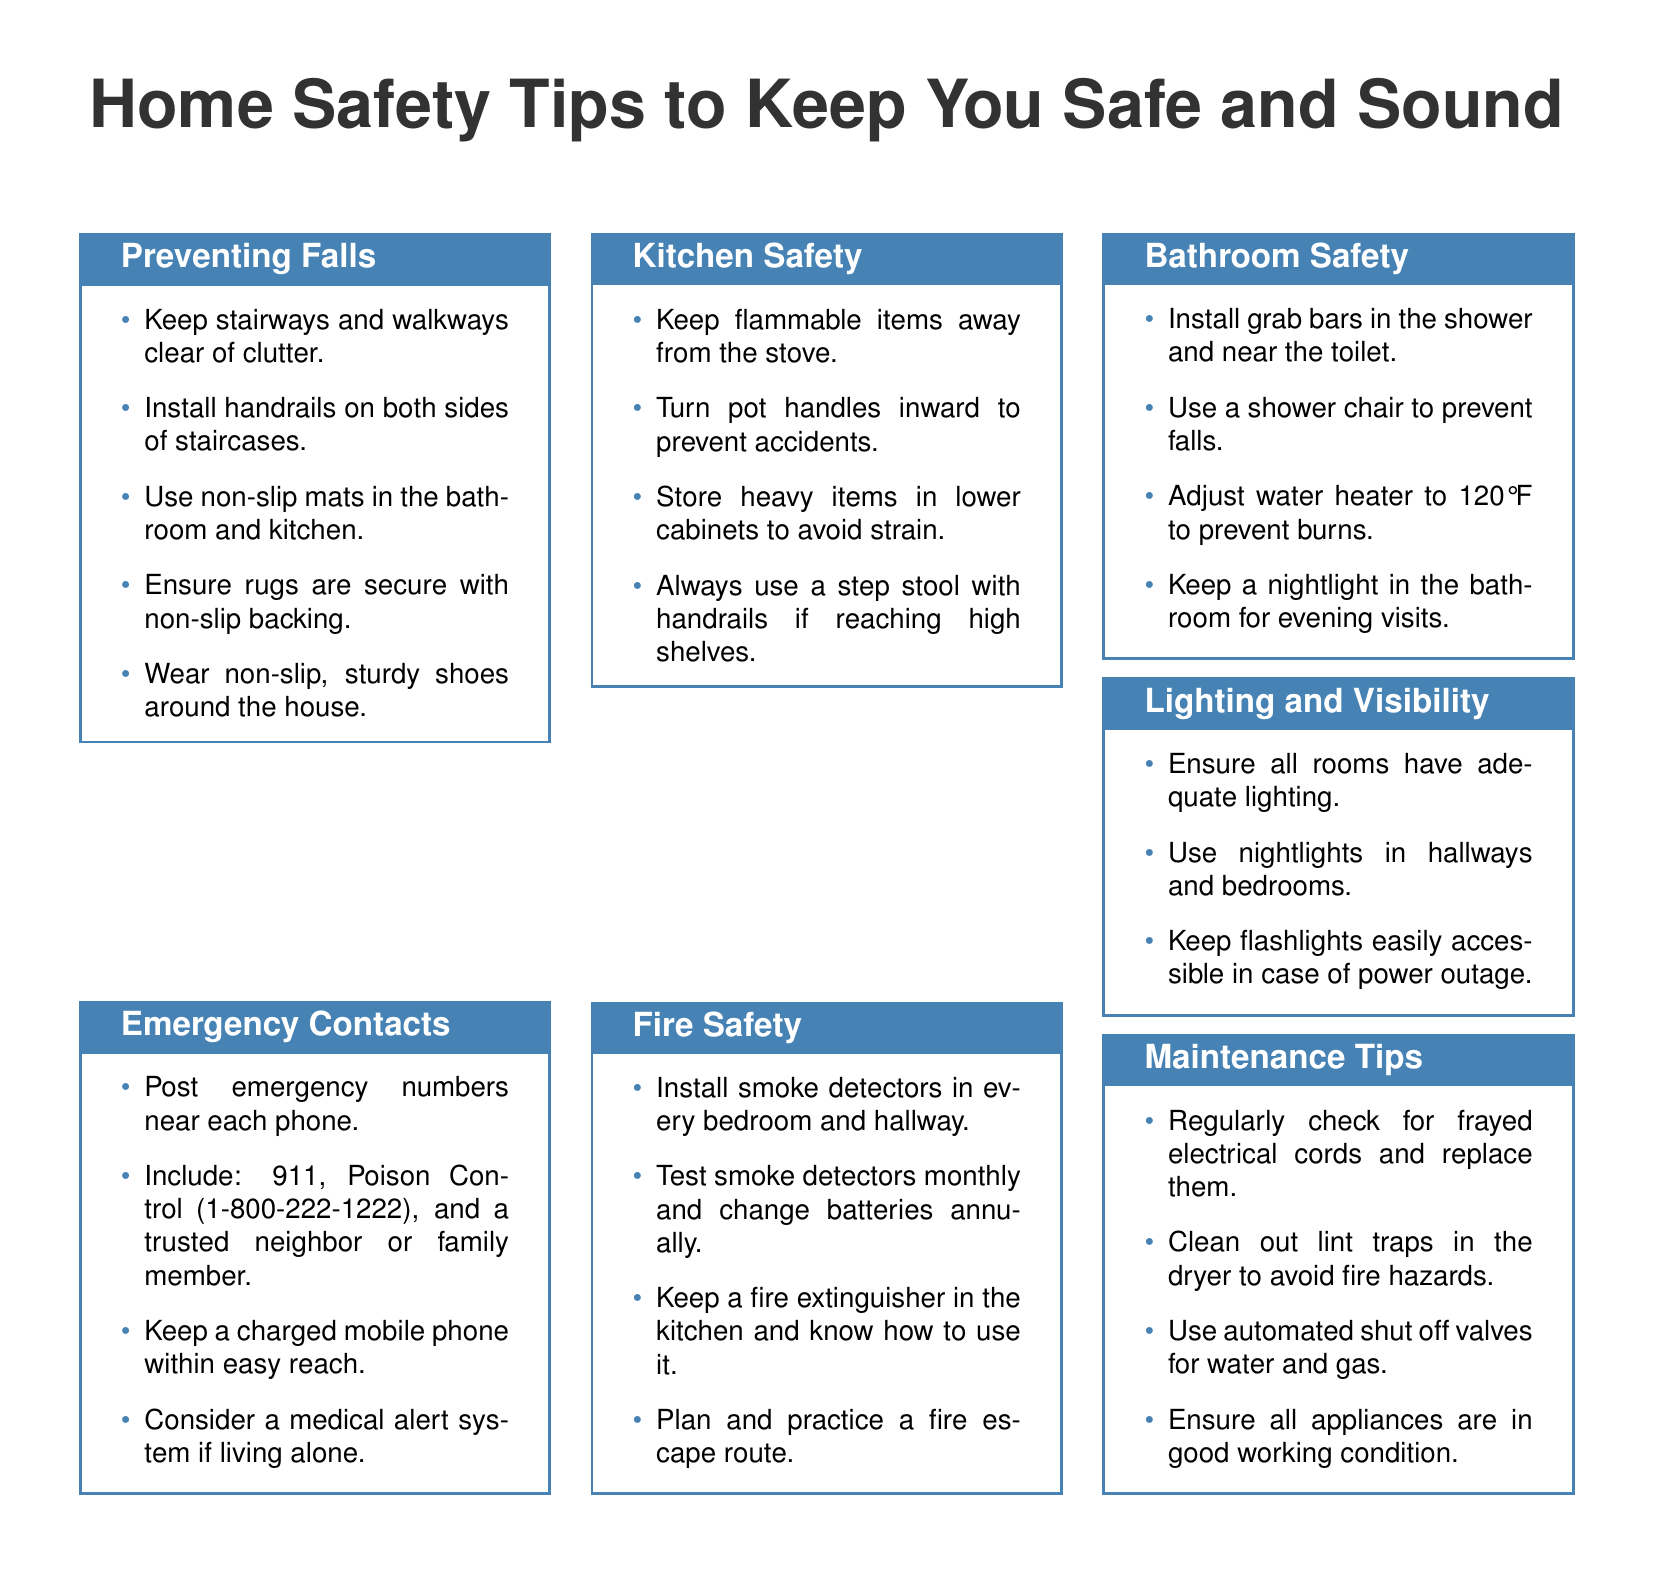What are two items to keep near each phone? The document lists emergency numbers, including 911 and Poison Control, that should be posted near each phone.
Answer: 911, Poison Control How many smoke detectors should be installed? The document states that smoke detectors should be installed in every bedroom and hallway, implying multiple units.
Answer: Every bedroom and hallway What is one tip for preventing falls? The document mentions keeping stairways and walkways clear of clutter as a safety measure to prevent falls.
Answer: Keep stairways clear Which bathroom feature is recommended to prevent falls? The document suggests installing grab bars in the shower and near the toilet to enhance bathroom safety.
Answer: Grab bars What temperature should the water heater be set to? According to the document, the water heater should be adjusted to prevent burns.
Answer: 120°F What should be done with frayed electrical cords? The document indicates that frayed electrical cords should be checked regularly and replaced to avoid hazards.
Answer: Replace them What is one of the lighting recommendations? The document recommends ensuring all rooms have adequate lighting for better visibility.
Answer: Adequate lighting How often should smoke detectors be tested? The document states that smoke detectors should be tested monthly as a part of fire safety measures.
Answer: Monthly 